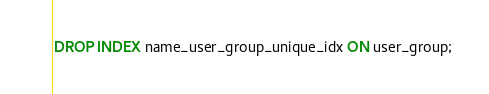<code> <loc_0><loc_0><loc_500><loc_500><_SQL_>DROP INDEX name_user_group_unique_idx ON user_group;</code> 